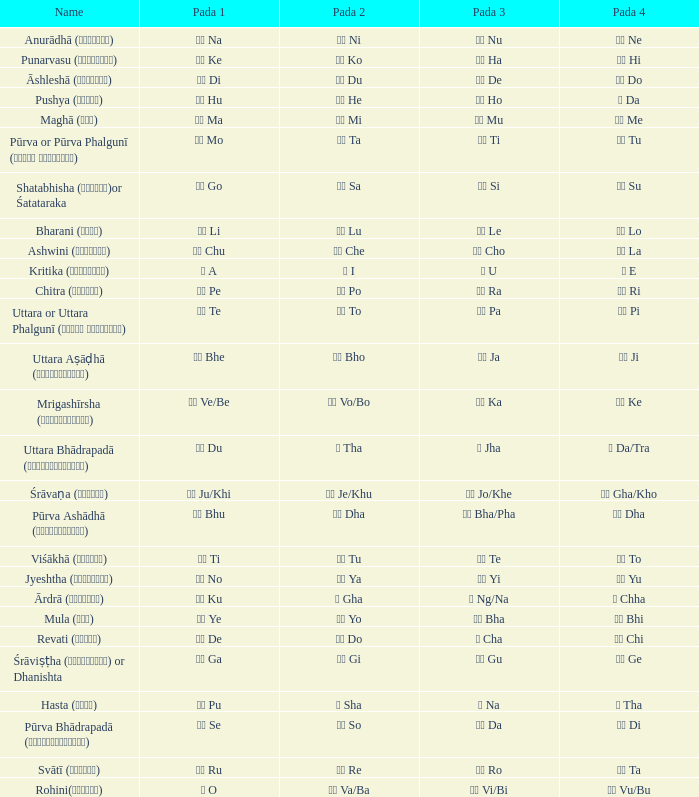Which pada 3 has a pada 2 of चे che? चो Cho. 